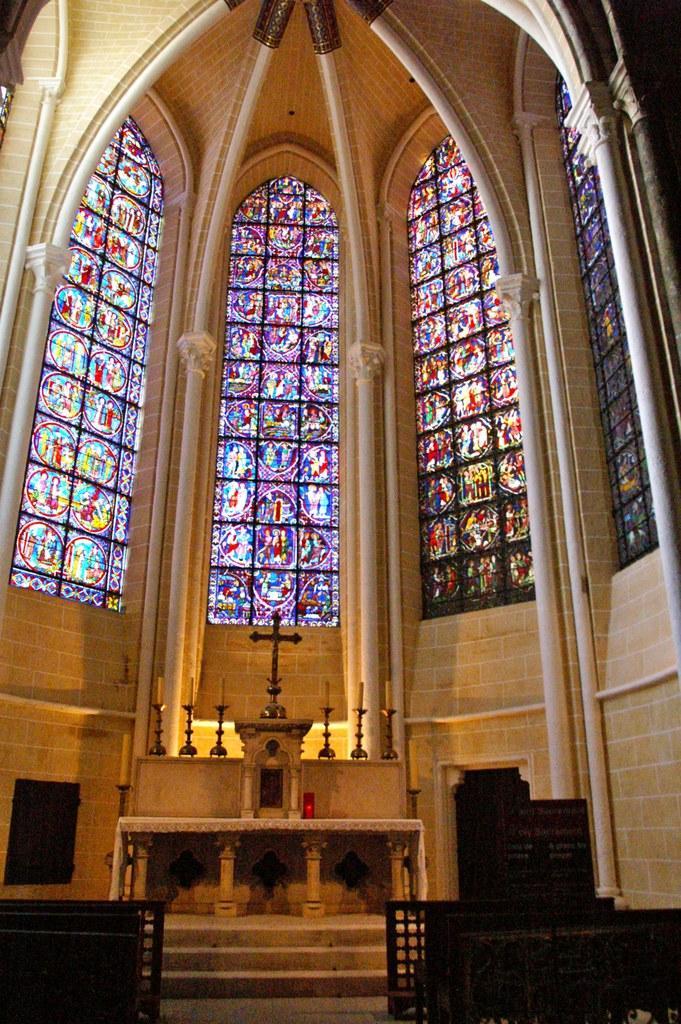Can you describe this image briefly? In the foreground of the image we can see benches. In the middle of the image we can see candles and plus symbol. On the top of the image we can see a colored glass window. 